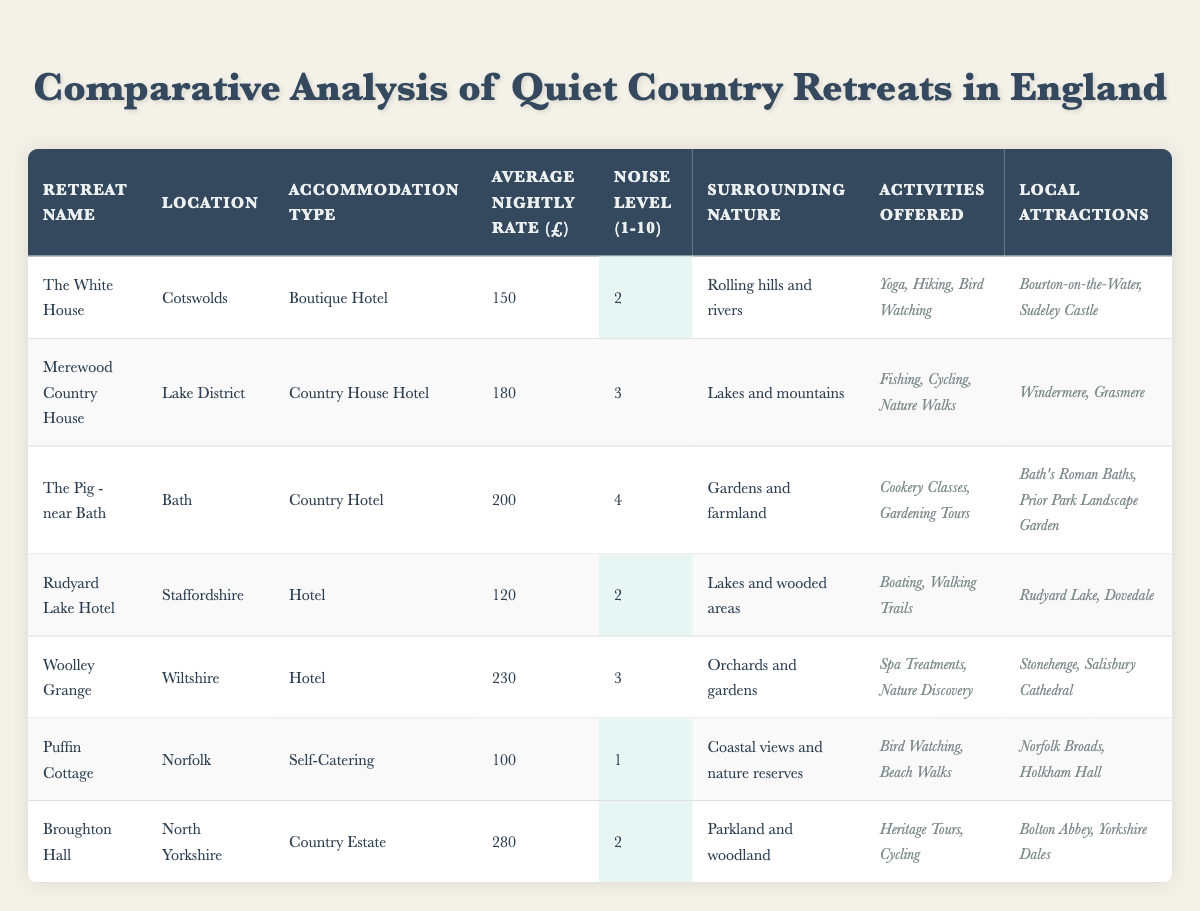What is the average nightly rate of "The Pig - near Bath"? The average nightly rate for "The Pig - near Bath" is £200, as noted in the table under the "Average Nightly Rate (£)" column for this retreat.
Answer: £200 Which retreat has the highest noise level? The retreat with the highest noise level is "The Pig - near Bath," which has a noise level of 4 out of 10. This is determined by checking the noise levels listed for each retreat in the table.
Answer: The Pig - near Bath Is Puffin Cottage quieter than The White House? Yes, Puffin Cottage has a noise level of 1, while The White House has a noise level of 2. This can be verified by comparing the respective noise level entries for these retreats in the table.
Answer: Yes What types of activities are offered at Merewood Country House? Merewood Country House offers Fishing, Cycling, and Nature Walks, as indicated in the "Activities Offered" column for this retreat.
Answer: Fishing, Cycling, Nature Walks What is the total average nightly rate of the retreats with a noise level of 2? The retreats with a noise level of 2 are "The White House," "Rudyard Lake Hotel," and "Broughton Hall." Their average nightly rates are £150, £120, and £280, respectively. The total is £150 + £120 + £280 = £550, and the average is £550 / 3 = approximately £183.33.
Answer: Approximately £183.33 Are there any retreats located in the Lake District? Yes, "Merewood Country House" is located in the Lake District, as specified in the location column for this retreat in the table.
Answer: Yes Which retreat offers the most expensive nightly rate, and how much is it? The most expensive nightly rate is offered by "Broughton Hall," priced at £280, as listed under the "Average Nightly Rate (£)" column.
Answer: £280 How many retreats have a noise level of 3 or lower? There are four retreats with a noise level of 3 or lower: "The White House," "Rudyard Lake Hotel," "Merewood Country House," and "Woolley Grange." Therefore, the total count is 4.
Answer: 4 Which local attractions are offered by Puffin Cottage? Puffin Cottage offers local attractions such as the Norfolk Broads and Holkham Hall, as specified in the "Local Attractions" column for this retreat.
Answer: Norfolk Broads, Holkham Hall If one were to visit all the local attractions for "Woolley Grange," how many total attractions can they expect? "Woolley Grange" has two local attractions: Stonehenge and Salisbury Cathedral. Therefore, a visitor can expect a total of 2 attractions.
Answer: 2 What is the average noise level of all the listed retreats? The noise levels for the retreats are 2, 3, 4, 2, 3, 1, and 2, which sum to 17. Dividing this by the total number of retreats (7) gives an average noise level of approximately 2.43.
Answer: Approximately 2.43 